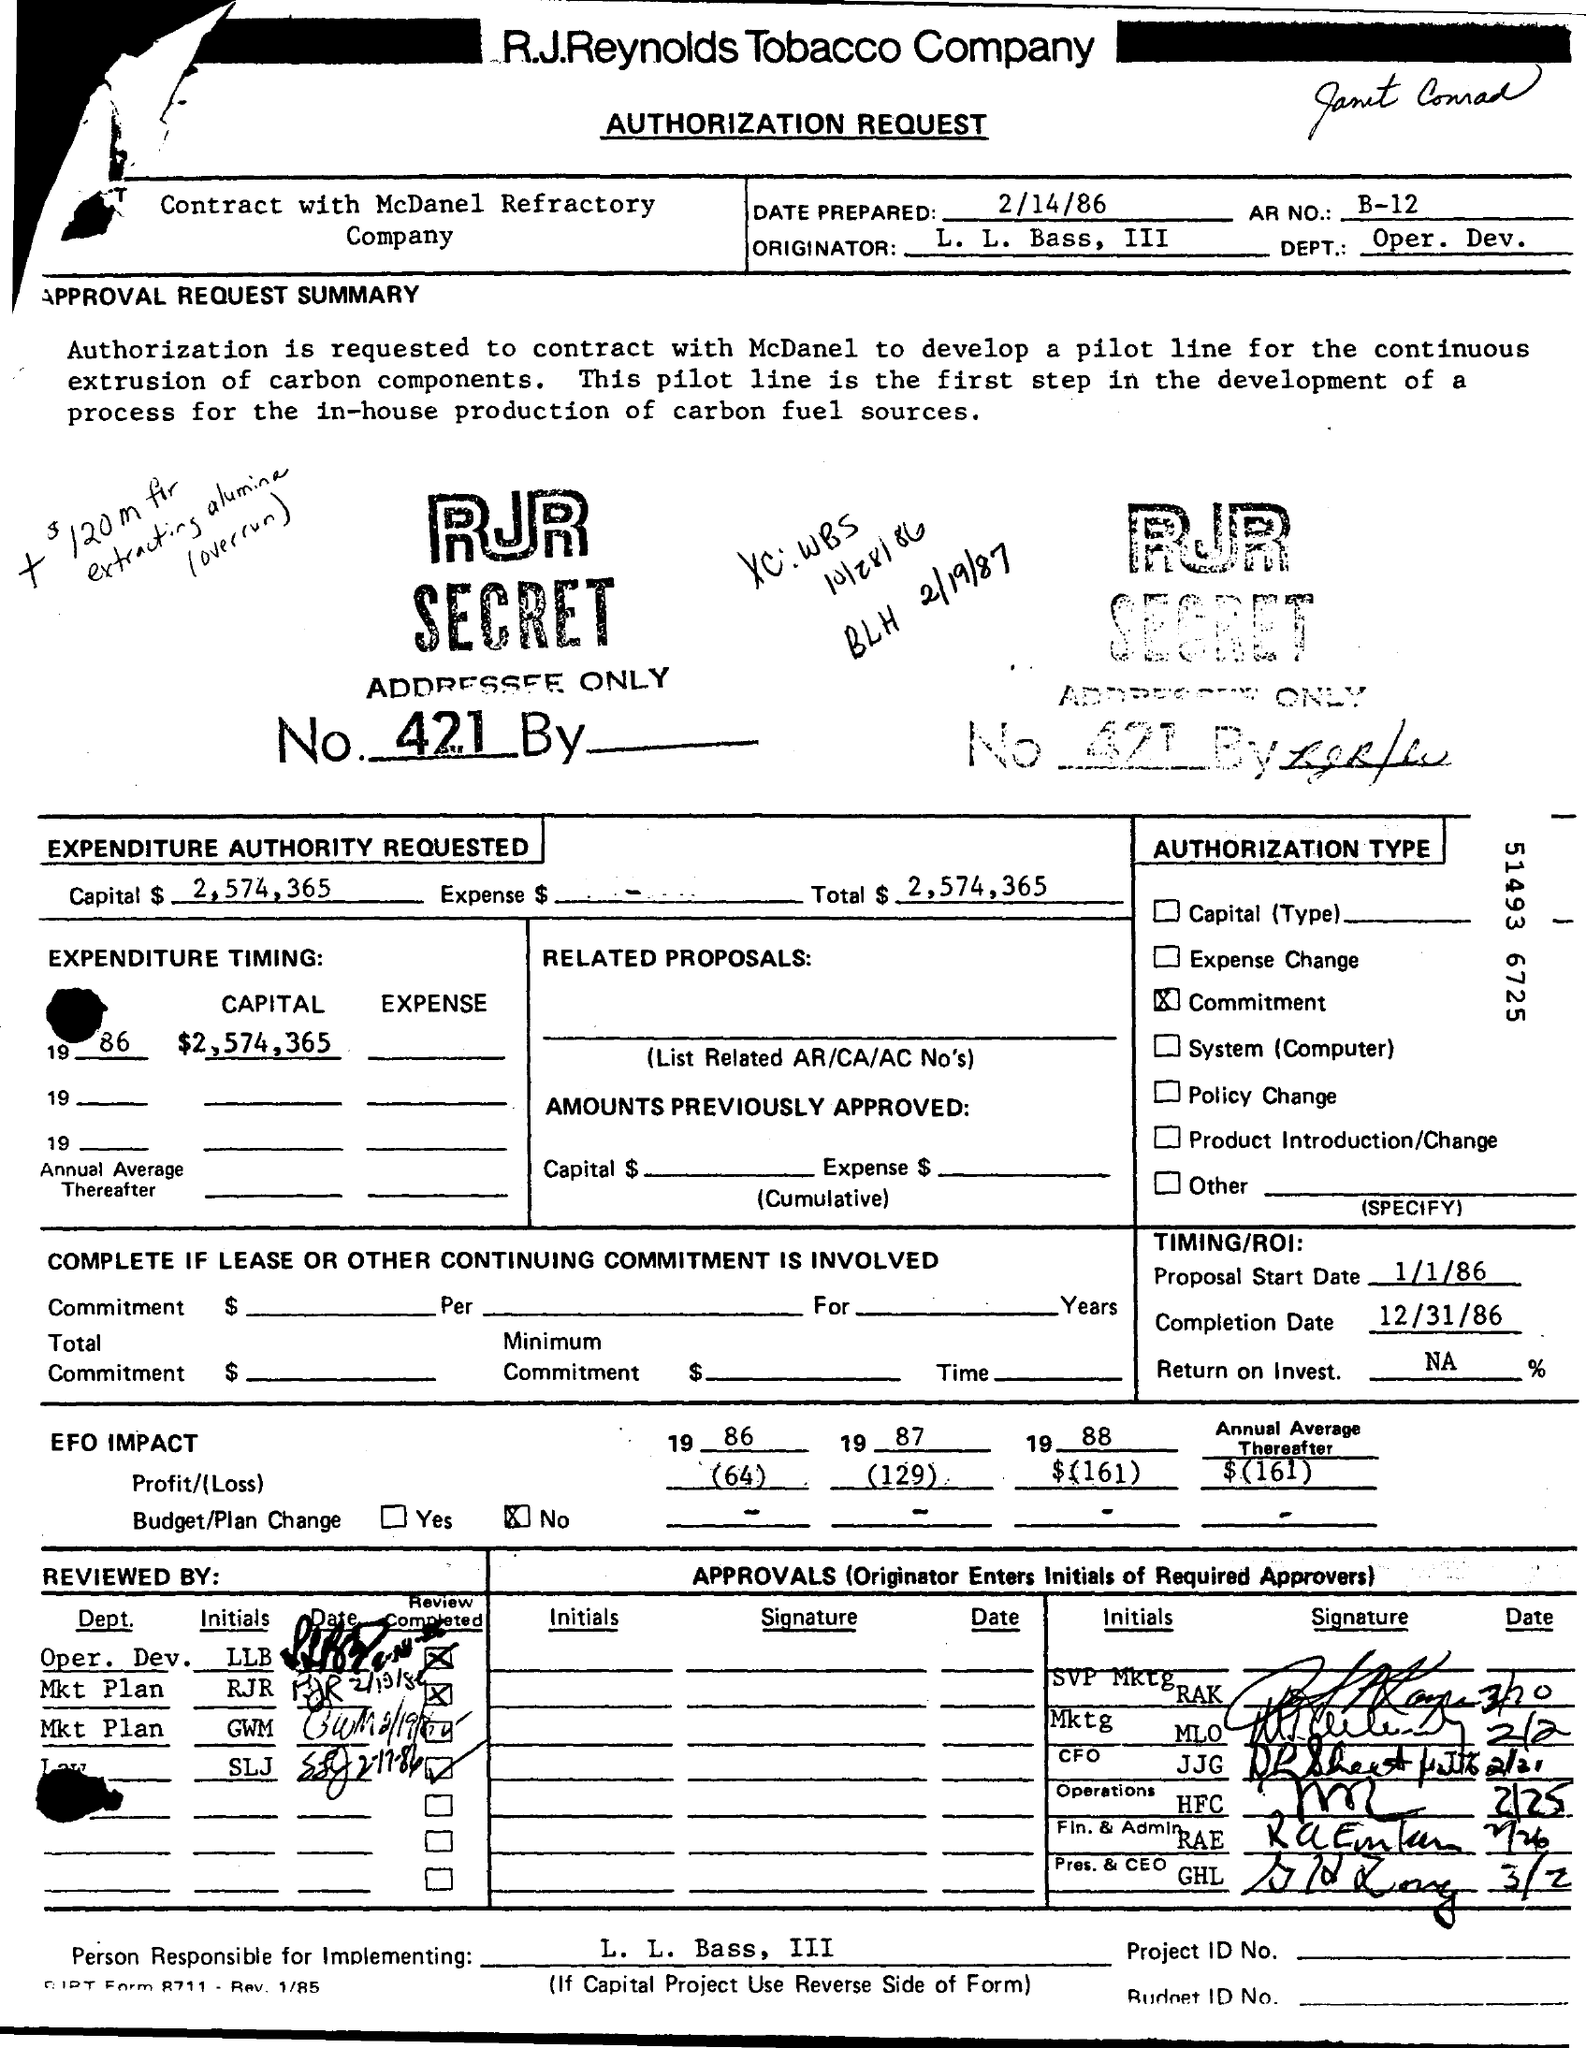What is the Date Prepared?
Your response must be concise. 2/14/86. Who is the Originator?
Give a very brief answer. L. L. Bass, III. What is the Dept.?
Give a very brief answer. Oper. Dev. What is the AR NO.?
Provide a short and direct response. B-12. What is the Capital?
Make the answer very short. $2,574,365. What is the Proposal Start Date?
Give a very brief answer. 1/1/86. What is the Completion Date?
Ensure brevity in your answer.  12/31/86. Who is the Person Responsible for Implementing?
Offer a terse response. L. L. Bass, III. 